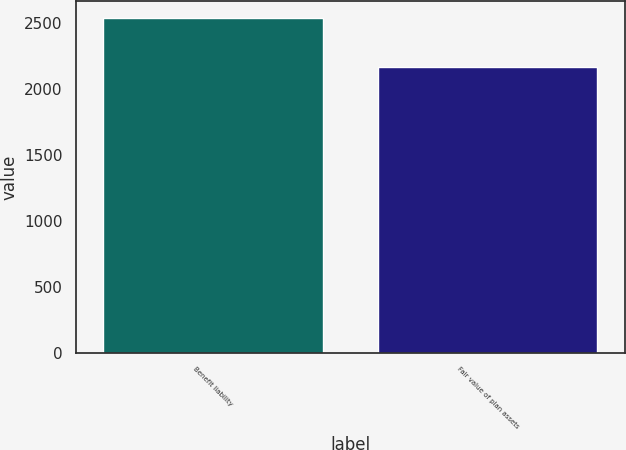Convert chart to OTSL. <chart><loc_0><loc_0><loc_500><loc_500><bar_chart><fcel>Benefit liability<fcel>Fair value of plan assets<nl><fcel>2542<fcel>2166<nl></chart> 